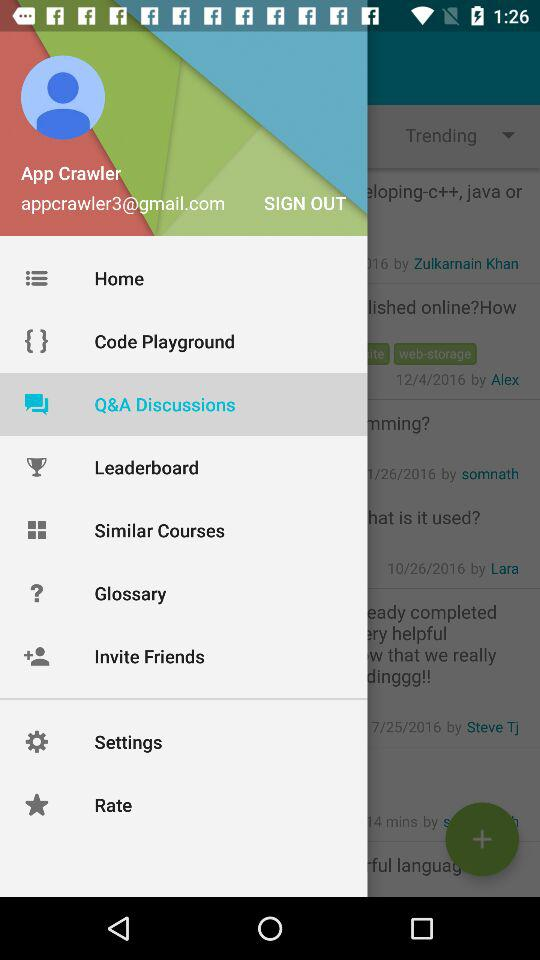What's the user profile name? The user profile name is App Crawler. 